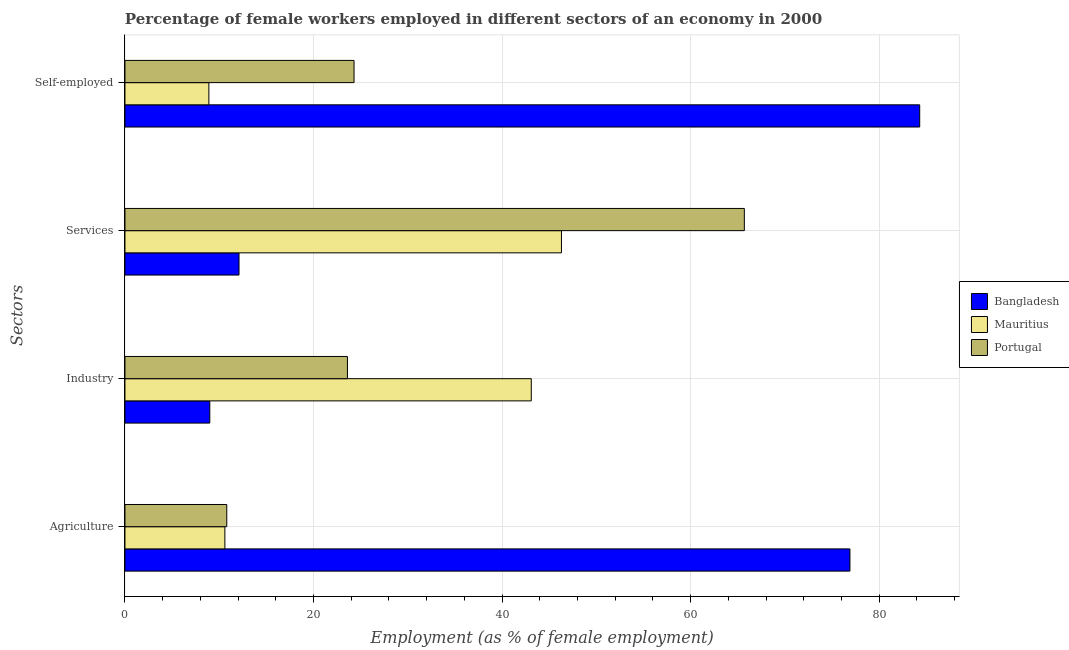How many different coloured bars are there?
Offer a terse response. 3. How many groups of bars are there?
Offer a terse response. 4. Are the number of bars on each tick of the Y-axis equal?
Provide a succinct answer. Yes. How many bars are there on the 3rd tick from the top?
Your answer should be compact. 3. How many bars are there on the 3rd tick from the bottom?
Offer a very short reply. 3. What is the label of the 4th group of bars from the top?
Provide a succinct answer. Agriculture. What is the percentage of self employed female workers in Portugal?
Your response must be concise. 24.3. Across all countries, what is the maximum percentage of female workers in industry?
Ensure brevity in your answer.  43.1. Across all countries, what is the minimum percentage of self employed female workers?
Keep it short and to the point. 8.9. In which country was the percentage of female workers in industry maximum?
Your response must be concise. Mauritius. In which country was the percentage of female workers in agriculture minimum?
Your response must be concise. Mauritius. What is the total percentage of female workers in industry in the graph?
Offer a terse response. 75.7. What is the difference between the percentage of self employed female workers in Mauritius and that in Bangladesh?
Provide a succinct answer. -75.4. What is the difference between the percentage of self employed female workers in Portugal and the percentage of female workers in agriculture in Bangladesh?
Your answer should be compact. -52.6. What is the average percentage of female workers in services per country?
Keep it short and to the point. 41.37. What is the difference between the percentage of female workers in industry and percentage of female workers in agriculture in Mauritius?
Keep it short and to the point. 32.5. What is the ratio of the percentage of female workers in agriculture in Bangladesh to that in Mauritius?
Provide a succinct answer. 7.25. Is the difference between the percentage of female workers in services in Portugal and Bangladesh greater than the difference between the percentage of female workers in industry in Portugal and Bangladesh?
Provide a short and direct response. Yes. What is the difference between the highest and the second highest percentage of female workers in services?
Your response must be concise. 19.4. What is the difference between the highest and the lowest percentage of self employed female workers?
Your answer should be compact. 75.4. What does the 3rd bar from the top in Industry represents?
Your response must be concise. Bangladesh. What does the 3rd bar from the bottom in Agriculture represents?
Your answer should be compact. Portugal. Is it the case that in every country, the sum of the percentage of female workers in agriculture and percentage of female workers in industry is greater than the percentage of female workers in services?
Your response must be concise. No. What is the difference between two consecutive major ticks on the X-axis?
Your response must be concise. 20. Are the values on the major ticks of X-axis written in scientific E-notation?
Your answer should be very brief. No. Does the graph contain any zero values?
Make the answer very short. No. Does the graph contain grids?
Offer a very short reply. Yes. Where does the legend appear in the graph?
Provide a short and direct response. Center right. How many legend labels are there?
Your response must be concise. 3. What is the title of the graph?
Provide a short and direct response. Percentage of female workers employed in different sectors of an economy in 2000. What is the label or title of the X-axis?
Your answer should be compact. Employment (as % of female employment). What is the label or title of the Y-axis?
Offer a very short reply. Sectors. What is the Employment (as % of female employment) in Bangladesh in Agriculture?
Offer a terse response. 76.9. What is the Employment (as % of female employment) in Mauritius in Agriculture?
Make the answer very short. 10.6. What is the Employment (as % of female employment) in Portugal in Agriculture?
Keep it short and to the point. 10.8. What is the Employment (as % of female employment) in Bangladesh in Industry?
Your response must be concise. 9. What is the Employment (as % of female employment) of Mauritius in Industry?
Your answer should be compact. 43.1. What is the Employment (as % of female employment) of Portugal in Industry?
Make the answer very short. 23.6. What is the Employment (as % of female employment) of Bangladesh in Services?
Your answer should be very brief. 12.1. What is the Employment (as % of female employment) in Mauritius in Services?
Keep it short and to the point. 46.3. What is the Employment (as % of female employment) in Portugal in Services?
Provide a succinct answer. 65.7. What is the Employment (as % of female employment) of Bangladesh in Self-employed?
Provide a succinct answer. 84.3. What is the Employment (as % of female employment) of Mauritius in Self-employed?
Give a very brief answer. 8.9. What is the Employment (as % of female employment) in Portugal in Self-employed?
Keep it short and to the point. 24.3. Across all Sectors, what is the maximum Employment (as % of female employment) of Bangladesh?
Provide a succinct answer. 84.3. Across all Sectors, what is the maximum Employment (as % of female employment) in Mauritius?
Keep it short and to the point. 46.3. Across all Sectors, what is the maximum Employment (as % of female employment) of Portugal?
Offer a terse response. 65.7. Across all Sectors, what is the minimum Employment (as % of female employment) of Bangladesh?
Provide a succinct answer. 9. Across all Sectors, what is the minimum Employment (as % of female employment) in Mauritius?
Offer a terse response. 8.9. Across all Sectors, what is the minimum Employment (as % of female employment) of Portugal?
Your answer should be compact. 10.8. What is the total Employment (as % of female employment) in Bangladesh in the graph?
Ensure brevity in your answer.  182.3. What is the total Employment (as % of female employment) in Mauritius in the graph?
Provide a succinct answer. 108.9. What is the total Employment (as % of female employment) in Portugal in the graph?
Make the answer very short. 124.4. What is the difference between the Employment (as % of female employment) of Bangladesh in Agriculture and that in Industry?
Give a very brief answer. 67.9. What is the difference between the Employment (as % of female employment) of Mauritius in Agriculture and that in Industry?
Your answer should be compact. -32.5. What is the difference between the Employment (as % of female employment) in Portugal in Agriculture and that in Industry?
Give a very brief answer. -12.8. What is the difference between the Employment (as % of female employment) in Bangladesh in Agriculture and that in Services?
Make the answer very short. 64.8. What is the difference between the Employment (as % of female employment) of Mauritius in Agriculture and that in Services?
Keep it short and to the point. -35.7. What is the difference between the Employment (as % of female employment) of Portugal in Agriculture and that in Services?
Offer a terse response. -54.9. What is the difference between the Employment (as % of female employment) of Bangladesh in Agriculture and that in Self-employed?
Your response must be concise. -7.4. What is the difference between the Employment (as % of female employment) of Mauritius in Agriculture and that in Self-employed?
Provide a succinct answer. 1.7. What is the difference between the Employment (as % of female employment) in Bangladesh in Industry and that in Services?
Ensure brevity in your answer.  -3.1. What is the difference between the Employment (as % of female employment) of Mauritius in Industry and that in Services?
Give a very brief answer. -3.2. What is the difference between the Employment (as % of female employment) of Portugal in Industry and that in Services?
Your answer should be very brief. -42.1. What is the difference between the Employment (as % of female employment) in Bangladesh in Industry and that in Self-employed?
Your answer should be compact. -75.3. What is the difference between the Employment (as % of female employment) of Mauritius in Industry and that in Self-employed?
Offer a terse response. 34.2. What is the difference between the Employment (as % of female employment) of Portugal in Industry and that in Self-employed?
Keep it short and to the point. -0.7. What is the difference between the Employment (as % of female employment) of Bangladesh in Services and that in Self-employed?
Give a very brief answer. -72.2. What is the difference between the Employment (as % of female employment) of Mauritius in Services and that in Self-employed?
Make the answer very short. 37.4. What is the difference between the Employment (as % of female employment) in Portugal in Services and that in Self-employed?
Provide a short and direct response. 41.4. What is the difference between the Employment (as % of female employment) of Bangladesh in Agriculture and the Employment (as % of female employment) of Mauritius in Industry?
Your answer should be compact. 33.8. What is the difference between the Employment (as % of female employment) of Bangladesh in Agriculture and the Employment (as % of female employment) of Portugal in Industry?
Provide a short and direct response. 53.3. What is the difference between the Employment (as % of female employment) in Bangladesh in Agriculture and the Employment (as % of female employment) in Mauritius in Services?
Your response must be concise. 30.6. What is the difference between the Employment (as % of female employment) of Mauritius in Agriculture and the Employment (as % of female employment) of Portugal in Services?
Give a very brief answer. -55.1. What is the difference between the Employment (as % of female employment) in Bangladesh in Agriculture and the Employment (as % of female employment) in Mauritius in Self-employed?
Ensure brevity in your answer.  68. What is the difference between the Employment (as % of female employment) of Bangladesh in Agriculture and the Employment (as % of female employment) of Portugal in Self-employed?
Offer a very short reply. 52.6. What is the difference between the Employment (as % of female employment) of Mauritius in Agriculture and the Employment (as % of female employment) of Portugal in Self-employed?
Keep it short and to the point. -13.7. What is the difference between the Employment (as % of female employment) in Bangladesh in Industry and the Employment (as % of female employment) in Mauritius in Services?
Provide a succinct answer. -37.3. What is the difference between the Employment (as % of female employment) in Bangladesh in Industry and the Employment (as % of female employment) in Portugal in Services?
Your answer should be compact. -56.7. What is the difference between the Employment (as % of female employment) in Mauritius in Industry and the Employment (as % of female employment) in Portugal in Services?
Your answer should be compact. -22.6. What is the difference between the Employment (as % of female employment) in Bangladesh in Industry and the Employment (as % of female employment) in Mauritius in Self-employed?
Give a very brief answer. 0.1. What is the difference between the Employment (as % of female employment) in Bangladesh in Industry and the Employment (as % of female employment) in Portugal in Self-employed?
Your answer should be very brief. -15.3. What is the difference between the Employment (as % of female employment) in Mauritius in Industry and the Employment (as % of female employment) in Portugal in Self-employed?
Keep it short and to the point. 18.8. What is the average Employment (as % of female employment) in Bangladesh per Sectors?
Your answer should be compact. 45.58. What is the average Employment (as % of female employment) of Mauritius per Sectors?
Offer a very short reply. 27.23. What is the average Employment (as % of female employment) in Portugal per Sectors?
Offer a terse response. 31.1. What is the difference between the Employment (as % of female employment) of Bangladesh and Employment (as % of female employment) of Mauritius in Agriculture?
Keep it short and to the point. 66.3. What is the difference between the Employment (as % of female employment) in Bangladesh and Employment (as % of female employment) in Portugal in Agriculture?
Offer a very short reply. 66.1. What is the difference between the Employment (as % of female employment) of Bangladesh and Employment (as % of female employment) of Mauritius in Industry?
Provide a short and direct response. -34.1. What is the difference between the Employment (as % of female employment) in Bangladesh and Employment (as % of female employment) in Portugal in Industry?
Provide a succinct answer. -14.6. What is the difference between the Employment (as % of female employment) in Mauritius and Employment (as % of female employment) in Portugal in Industry?
Your answer should be very brief. 19.5. What is the difference between the Employment (as % of female employment) of Bangladesh and Employment (as % of female employment) of Mauritius in Services?
Provide a succinct answer. -34.2. What is the difference between the Employment (as % of female employment) in Bangladesh and Employment (as % of female employment) in Portugal in Services?
Give a very brief answer. -53.6. What is the difference between the Employment (as % of female employment) of Mauritius and Employment (as % of female employment) of Portugal in Services?
Offer a terse response. -19.4. What is the difference between the Employment (as % of female employment) in Bangladesh and Employment (as % of female employment) in Mauritius in Self-employed?
Offer a terse response. 75.4. What is the difference between the Employment (as % of female employment) in Bangladesh and Employment (as % of female employment) in Portugal in Self-employed?
Your response must be concise. 60. What is the difference between the Employment (as % of female employment) in Mauritius and Employment (as % of female employment) in Portugal in Self-employed?
Provide a succinct answer. -15.4. What is the ratio of the Employment (as % of female employment) of Bangladesh in Agriculture to that in Industry?
Your response must be concise. 8.54. What is the ratio of the Employment (as % of female employment) in Mauritius in Agriculture to that in Industry?
Offer a terse response. 0.25. What is the ratio of the Employment (as % of female employment) of Portugal in Agriculture to that in Industry?
Offer a terse response. 0.46. What is the ratio of the Employment (as % of female employment) in Bangladesh in Agriculture to that in Services?
Provide a short and direct response. 6.36. What is the ratio of the Employment (as % of female employment) in Mauritius in Agriculture to that in Services?
Offer a terse response. 0.23. What is the ratio of the Employment (as % of female employment) of Portugal in Agriculture to that in Services?
Offer a terse response. 0.16. What is the ratio of the Employment (as % of female employment) of Bangladesh in Agriculture to that in Self-employed?
Offer a terse response. 0.91. What is the ratio of the Employment (as % of female employment) in Mauritius in Agriculture to that in Self-employed?
Offer a very short reply. 1.19. What is the ratio of the Employment (as % of female employment) of Portugal in Agriculture to that in Self-employed?
Provide a short and direct response. 0.44. What is the ratio of the Employment (as % of female employment) in Bangladesh in Industry to that in Services?
Offer a very short reply. 0.74. What is the ratio of the Employment (as % of female employment) in Mauritius in Industry to that in Services?
Your answer should be compact. 0.93. What is the ratio of the Employment (as % of female employment) in Portugal in Industry to that in Services?
Give a very brief answer. 0.36. What is the ratio of the Employment (as % of female employment) of Bangladesh in Industry to that in Self-employed?
Your response must be concise. 0.11. What is the ratio of the Employment (as % of female employment) in Mauritius in Industry to that in Self-employed?
Keep it short and to the point. 4.84. What is the ratio of the Employment (as % of female employment) of Portugal in Industry to that in Self-employed?
Provide a succinct answer. 0.97. What is the ratio of the Employment (as % of female employment) in Bangladesh in Services to that in Self-employed?
Provide a short and direct response. 0.14. What is the ratio of the Employment (as % of female employment) of Mauritius in Services to that in Self-employed?
Provide a short and direct response. 5.2. What is the ratio of the Employment (as % of female employment) of Portugal in Services to that in Self-employed?
Keep it short and to the point. 2.7. What is the difference between the highest and the second highest Employment (as % of female employment) of Mauritius?
Provide a succinct answer. 3.2. What is the difference between the highest and the second highest Employment (as % of female employment) in Portugal?
Provide a succinct answer. 41.4. What is the difference between the highest and the lowest Employment (as % of female employment) of Bangladesh?
Keep it short and to the point. 75.3. What is the difference between the highest and the lowest Employment (as % of female employment) in Mauritius?
Give a very brief answer. 37.4. What is the difference between the highest and the lowest Employment (as % of female employment) in Portugal?
Offer a terse response. 54.9. 